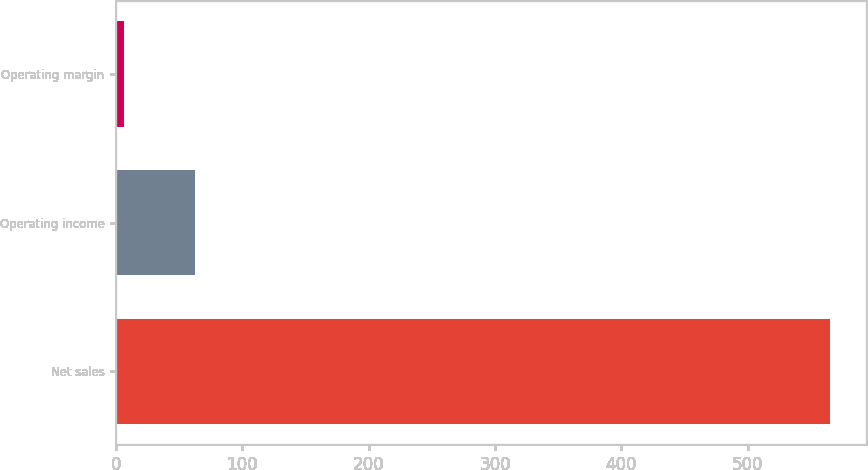Convert chart to OTSL. <chart><loc_0><loc_0><loc_500><loc_500><bar_chart><fcel>Net sales<fcel>Operating income<fcel>Operating margin<nl><fcel>565<fcel>62.26<fcel>6.4<nl></chart> 